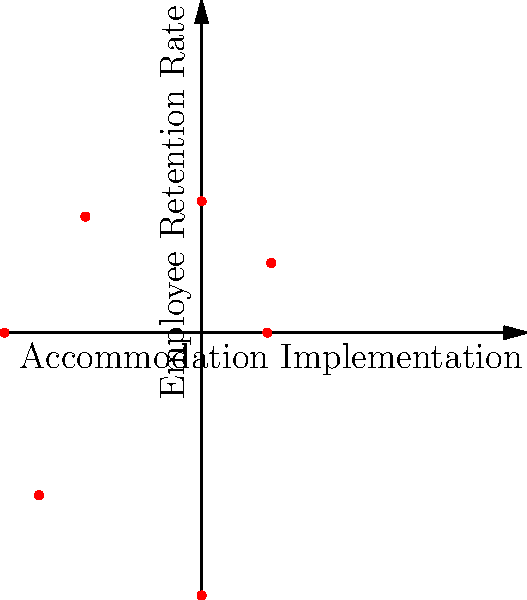Based on the polar scatter plot, which quadrant shows the highest concentration of data points, suggesting a strong positive correlation between accommodation implementation and employee retention rates? To answer this question, we need to analyze the distribution of data points in the polar scatter plot:

1. Recall that in polar coordinates, the angle (theta) represents the accommodation implementation, and the radius (r) represents the employee retention rate.

2. Divide the plot into four quadrants:
   - Quadrant I: 0° to 90°
   - Quadrant II: 90° to 180°
   - Quadrant III: 180° to 270°
   - Quadrant IV: 270° to 360°

3. Count the number of data points in each quadrant:
   - Quadrant I: 3 points
   - Quadrant II: 2 points
   - Quadrant III: 2 points
   - Quadrant IV: 0 points

4. Observe that Quadrant I has the highest concentration of data points (3).

5. In Quadrant I, both accommodation implementation (angle) and employee retention rate (radius) increase, indicating a positive correlation.

Therefore, Quadrant I shows the highest concentration of data points, suggesting a strong positive correlation between accommodation implementation and employee retention rates.
Answer: Quadrant I 